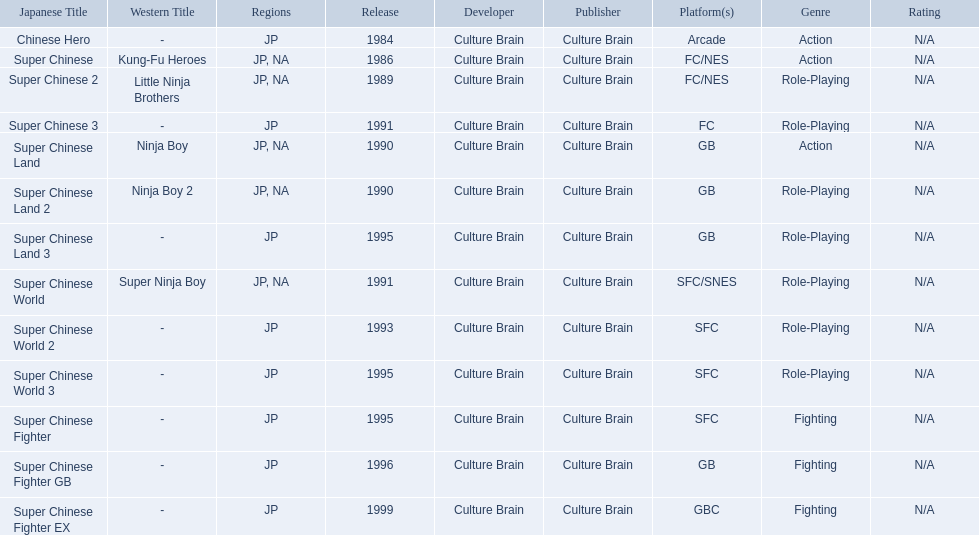What japanese titles were released in the north american (na) region? Super Chinese, Super Chinese 2, Super Chinese Land, Super Chinese Land 2, Super Chinese World. Of those, which one was released most recently? Super Chinese World. 